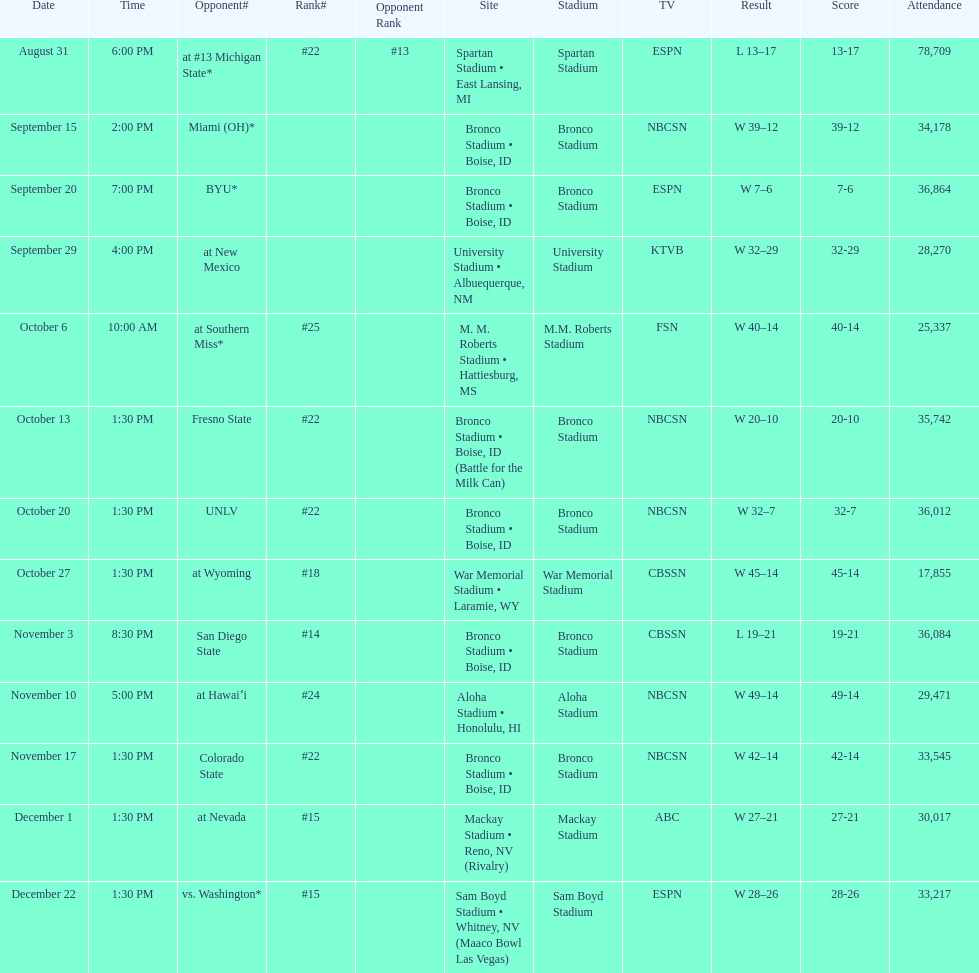Help me parse the entirety of this table. {'header': ['Date', 'Time', 'Opponent#', 'Rank#', 'Opponent Rank', 'Site', 'Stadium', 'TV', 'Result', 'Score', 'Attendance'], 'rows': [['August 31', '6:00 PM', 'at\xa0#13\xa0Michigan State*', '#22', '#13', 'Spartan Stadium • East Lansing, MI', 'Spartan Stadium', 'ESPN', 'L\xa013–17', '13-17', '78,709'], ['September 15', '2:00 PM', 'Miami (OH)*', '', '', 'Bronco Stadium • Boise, ID', 'Bronco Stadium', 'NBCSN', 'W\xa039–12', '39-12', '34,178'], ['September 20', '7:00 PM', 'BYU*', '', '', 'Bronco Stadium • Boise, ID', 'Bronco Stadium', 'ESPN', 'W\xa07–6', '7-6', '36,864'], ['September 29', '4:00 PM', 'at\xa0New Mexico', '', '', 'University Stadium • Albuequerque, NM', 'University Stadium', 'KTVB', 'W\xa032–29', '32-29', '28,270'], ['October 6', '10:00 AM', 'at\xa0Southern Miss*', '#25', '', 'M. M. Roberts Stadium • Hattiesburg, MS', 'M.M. Roberts Stadium', 'FSN', 'W\xa040–14', '40-14', '25,337'], ['October 13', '1:30 PM', 'Fresno State', '#22', '', 'Bronco Stadium • Boise, ID (Battle for the Milk Can)', 'Bronco Stadium', 'NBCSN', 'W\xa020–10', '20-10', '35,742'], ['October 20', '1:30 PM', 'UNLV', '#22', '', 'Bronco Stadium • Boise, ID', 'Bronco Stadium', 'NBCSN', 'W\xa032–7', '32-7', '36,012'], ['October 27', '1:30 PM', 'at\xa0Wyoming', '#18', '', 'War Memorial Stadium • Laramie, WY', 'War Memorial Stadium', 'CBSSN', 'W\xa045–14', '45-14', '17,855'], ['November 3', '8:30 PM', 'San Diego State', '#14', '', 'Bronco Stadium • Boise, ID', 'Bronco Stadium', 'CBSSN', 'L\xa019–21', '19-21', '36,084'], ['November 10', '5:00 PM', 'at\xa0Hawaiʻi', '#24', '', 'Aloha Stadium • Honolulu, HI', 'Aloha Stadium', 'NBCSN', 'W\xa049–14', '49-14', '29,471'], ['November 17', '1:30 PM', 'Colorado State', '#22', '', 'Bronco Stadium • Boise, ID', 'Bronco Stadium', 'NBCSN', 'W\xa042–14', '42-14', '33,545'], ['December 1', '1:30 PM', 'at\xa0Nevada', '#15', '', 'Mackay Stadium • Reno, NV (Rivalry)', 'Mackay Stadium', 'ABC', 'W\xa027–21', '27-21', '30,017'], ['December 22', '1:30 PM', 'vs.\xa0Washington*', '#15', '', 'Sam Boyd Stadium • Whitney, NV (Maaco Bowl Las Vegas)', 'Sam Boyd Stadium', 'ESPN', 'W\xa028–26', '28-26', '33,217']]} What is the score difference for the game against michigan state? 4. 